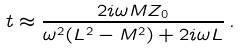<formula> <loc_0><loc_0><loc_500><loc_500>t \approx \frac { 2 i \omega M Z _ { 0 } } { \omega ^ { 2 } ( L ^ { 2 } - M ^ { 2 } ) + 2 i \omega L } \, .</formula> 